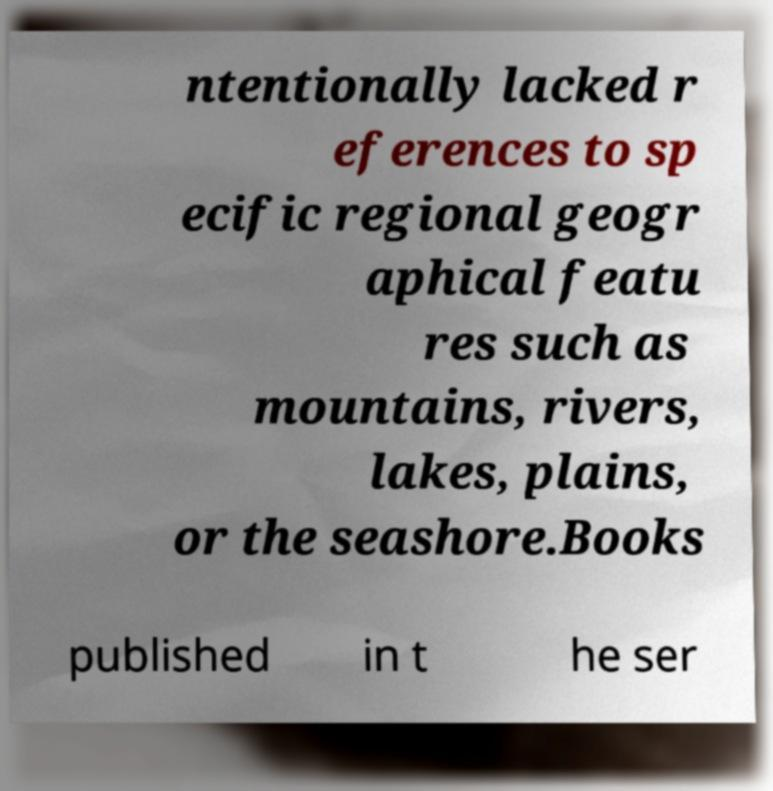Please identify and transcribe the text found in this image. ntentionally lacked r eferences to sp ecific regional geogr aphical featu res such as mountains, rivers, lakes, plains, or the seashore.Books published in t he ser 